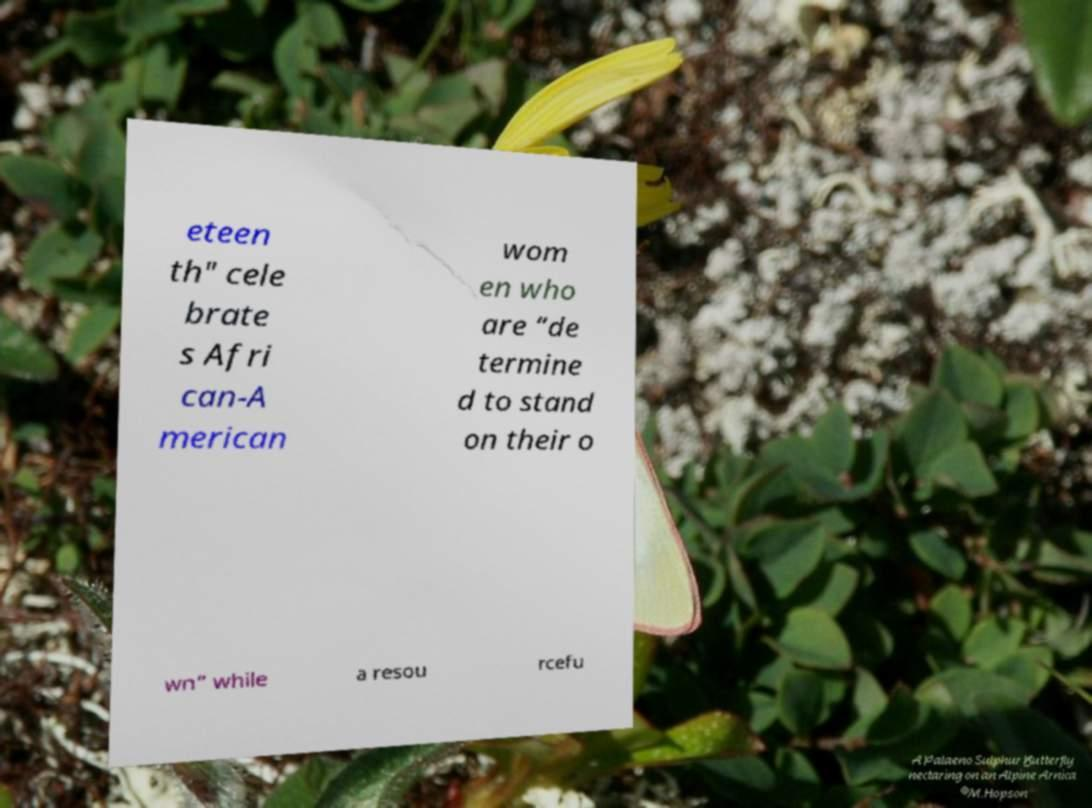Please identify and transcribe the text found in this image. eteen th" cele brate s Afri can-A merican wom en who are “de termine d to stand on their o wn” while a resou rcefu 